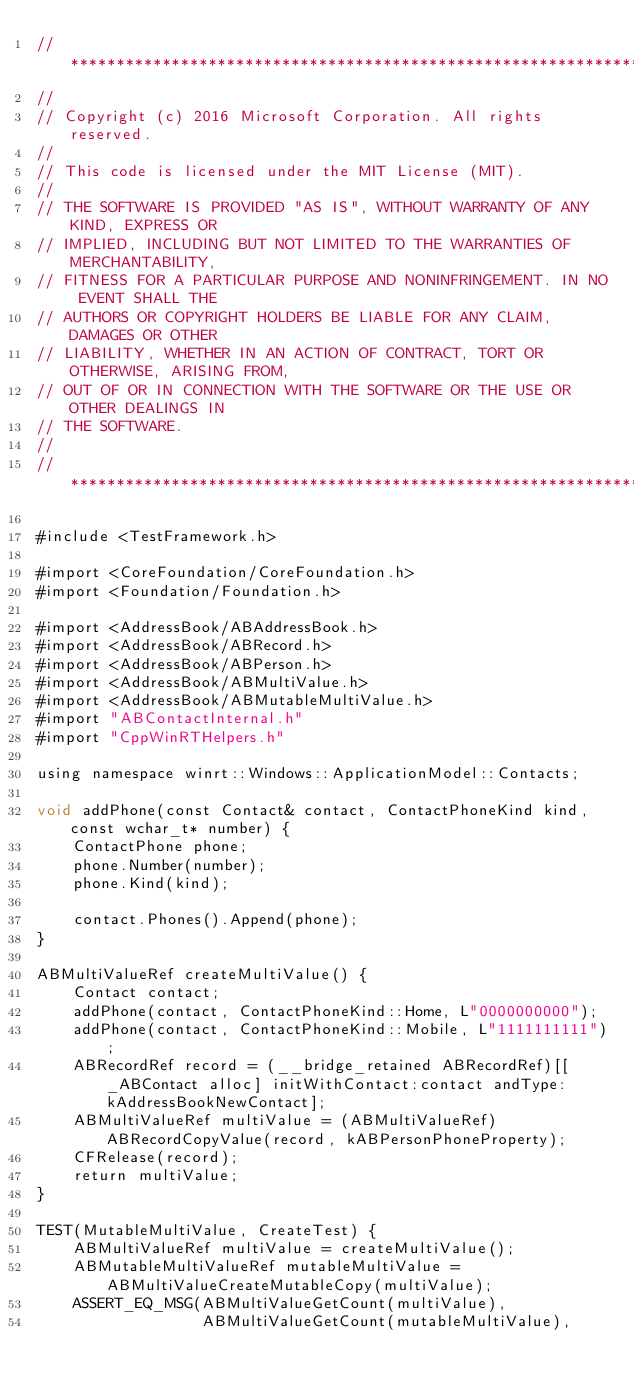<code> <loc_0><loc_0><loc_500><loc_500><_ObjectiveC_>//******************************************************************************
//
// Copyright (c) 2016 Microsoft Corporation. All rights reserved.
//
// This code is licensed under the MIT License (MIT).
//
// THE SOFTWARE IS PROVIDED "AS IS", WITHOUT WARRANTY OF ANY KIND, EXPRESS OR
// IMPLIED, INCLUDING BUT NOT LIMITED TO THE WARRANTIES OF MERCHANTABILITY,
// FITNESS FOR A PARTICULAR PURPOSE AND NONINFRINGEMENT. IN NO EVENT SHALL THE
// AUTHORS OR COPYRIGHT HOLDERS BE LIABLE FOR ANY CLAIM, DAMAGES OR OTHER
// LIABILITY, WHETHER IN AN ACTION OF CONTRACT, TORT OR OTHERWISE, ARISING FROM,
// OUT OF OR IN CONNECTION WITH THE SOFTWARE OR THE USE OR OTHER DEALINGS IN
// THE SOFTWARE.
//
//******************************************************************************

#include <TestFramework.h>

#import <CoreFoundation/CoreFoundation.h>
#import <Foundation/Foundation.h>

#import <AddressBook/ABAddressBook.h>
#import <AddressBook/ABRecord.h>
#import <AddressBook/ABPerson.h>
#import <AddressBook/ABMultiValue.h>
#import <AddressBook/ABMutableMultiValue.h>
#import "ABContactInternal.h"
#import "CppWinRTHelpers.h"

using namespace winrt::Windows::ApplicationModel::Contacts;

void addPhone(const Contact& contact, ContactPhoneKind kind, const wchar_t* number) {
    ContactPhone phone;
    phone.Number(number);
    phone.Kind(kind);

    contact.Phones().Append(phone);
}

ABMultiValueRef createMultiValue() {
    Contact contact;
    addPhone(contact, ContactPhoneKind::Home, L"0000000000");
    addPhone(contact, ContactPhoneKind::Mobile, L"1111111111");
    ABRecordRef record = (__bridge_retained ABRecordRef)[[_ABContact alloc] initWithContact:contact andType:kAddressBookNewContact];
    ABMultiValueRef multiValue = (ABMultiValueRef)ABRecordCopyValue(record, kABPersonPhoneProperty);
    CFRelease(record);
    return multiValue;
}

TEST(MutableMultiValue, CreateTest) {
    ABMultiValueRef multiValue = createMultiValue();
    ABMutableMultiValueRef mutableMultiValue = ABMultiValueCreateMutableCopy(multiValue);
    ASSERT_EQ_MSG(ABMultiValueGetCount(multiValue),
                  ABMultiValueGetCount(mutableMultiValue),</code> 